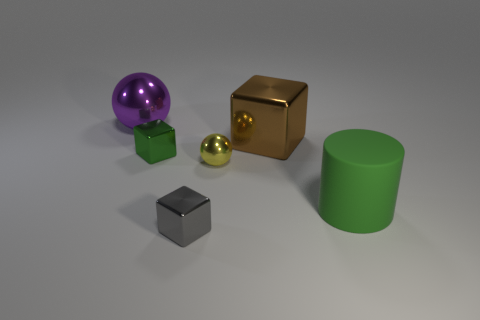What shape is the metal object that is the same color as the big matte thing?
Provide a short and direct response. Cube. What is the size of the block that is the same color as the cylinder?
Your response must be concise. Small. Do the brown shiny block and the green metallic object have the same size?
Ensure brevity in your answer.  No. What number of things are large cyan rubber things or objects behind the tiny yellow ball?
Offer a terse response. 3. What number of objects are either blocks that are in front of the small green shiny object or metallic blocks that are in front of the tiny yellow shiny ball?
Your answer should be very brief. 1. Are there any small blocks left of the gray thing?
Offer a very short reply. Yes. The large thing on the left side of the green thing that is to the left of the shiny thing on the right side of the yellow metal sphere is what color?
Your answer should be very brief. Purple. Is the yellow metal thing the same shape as the brown object?
Offer a terse response. No. What color is the other big object that is the same material as the brown thing?
Your response must be concise. Purple. How many objects are either green objects that are to the left of the small sphere or big purple metallic cylinders?
Your answer should be very brief. 1. 